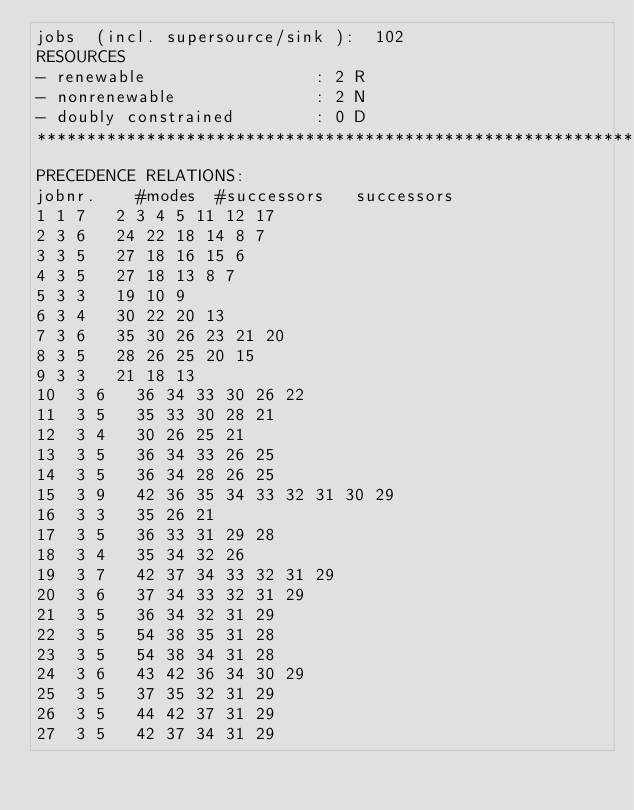<code> <loc_0><loc_0><loc_500><loc_500><_ObjectiveC_>jobs  (incl. supersource/sink ):	102
RESOURCES
- renewable                 : 2 R
- nonrenewable              : 2 N
- doubly constrained        : 0 D
************************************************************************
PRECEDENCE RELATIONS:
jobnr.    #modes  #successors   successors
1	1	7		2 3 4 5 11 12 17 
2	3	6		24 22 18 14 8 7 
3	3	5		27 18 16 15 6 
4	3	5		27 18 13 8 7 
5	3	3		19 10 9 
6	3	4		30 22 20 13 
7	3	6		35 30 26 23 21 20 
8	3	5		28 26 25 20 15 
9	3	3		21 18 13 
10	3	6		36 34 33 30 26 22 
11	3	5		35 33 30 28 21 
12	3	4		30 26 25 21 
13	3	5		36 34 33 26 25 
14	3	5		36 34 28 26 25 
15	3	9		42 36 35 34 33 32 31 30 29 
16	3	3		35 26 21 
17	3	5		36 33 31 29 28 
18	3	4		35 34 32 26 
19	3	7		42 37 34 33 32 31 29 
20	3	6		37 34 33 32 31 29 
21	3	5		36 34 32 31 29 
22	3	5		54 38 35 31 28 
23	3	5		54 38 34 31 28 
24	3	6		43 42 36 34 30 29 
25	3	5		37 35 32 31 29 
26	3	5		44 42 37 31 29 
27	3	5		42 37 34 31 29 </code> 